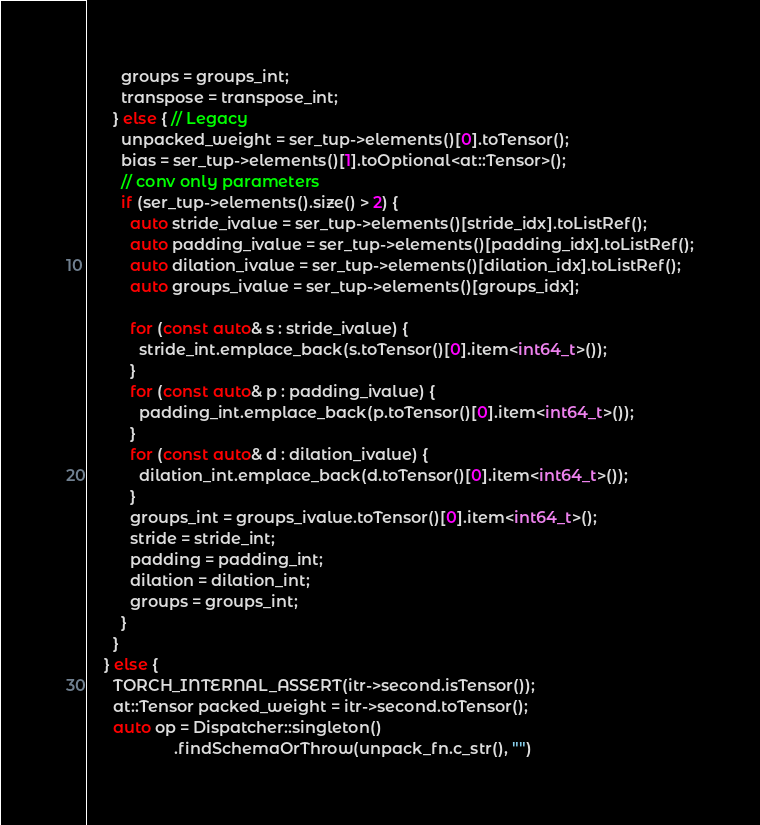<code> <loc_0><loc_0><loc_500><loc_500><_C++_>        groups = groups_int;
        transpose = transpose_int;
      } else { // Legacy
        unpacked_weight = ser_tup->elements()[0].toTensor();
        bias = ser_tup->elements()[1].toOptional<at::Tensor>();
        // conv only parameters
        if (ser_tup->elements().size() > 2) {
          auto stride_ivalue = ser_tup->elements()[stride_idx].toListRef();
          auto padding_ivalue = ser_tup->elements()[padding_idx].toListRef();
          auto dilation_ivalue = ser_tup->elements()[dilation_idx].toListRef();
          auto groups_ivalue = ser_tup->elements()[groups_idx];

          for (const auto& s : stride_ivalue) {
            stride_int.emplace_back(s.toTensor()[0].item<int64_t>());
          }
          for (const auto& p : padding_ivalue) {
            padding_int.emplace_back(p.toTensor()[0].item<int64_t>());
          }
          for (const auto& d : dilation_ivalue) {
            dilation_int.emplace_back(d.toTensor()[0].item<int64_t>());
          }
          groups_int = groups_ivalue.toTensor()[0].item<int64_t>();
          stride = stride_int;
          padding = padding_int;
          dilation = dilation_int;
          groups = groups_int;
        }
      }
    } else {
      TORCH_INTERNAL_ASSERT(itr->second.isTensor());
      at::Tensor packed_weight = itr->second.toTensor();
      auto op = Dispatcher::singleton()
                    .findSchemaOrThrow(unpack_fn.c_str(), "")</code> 